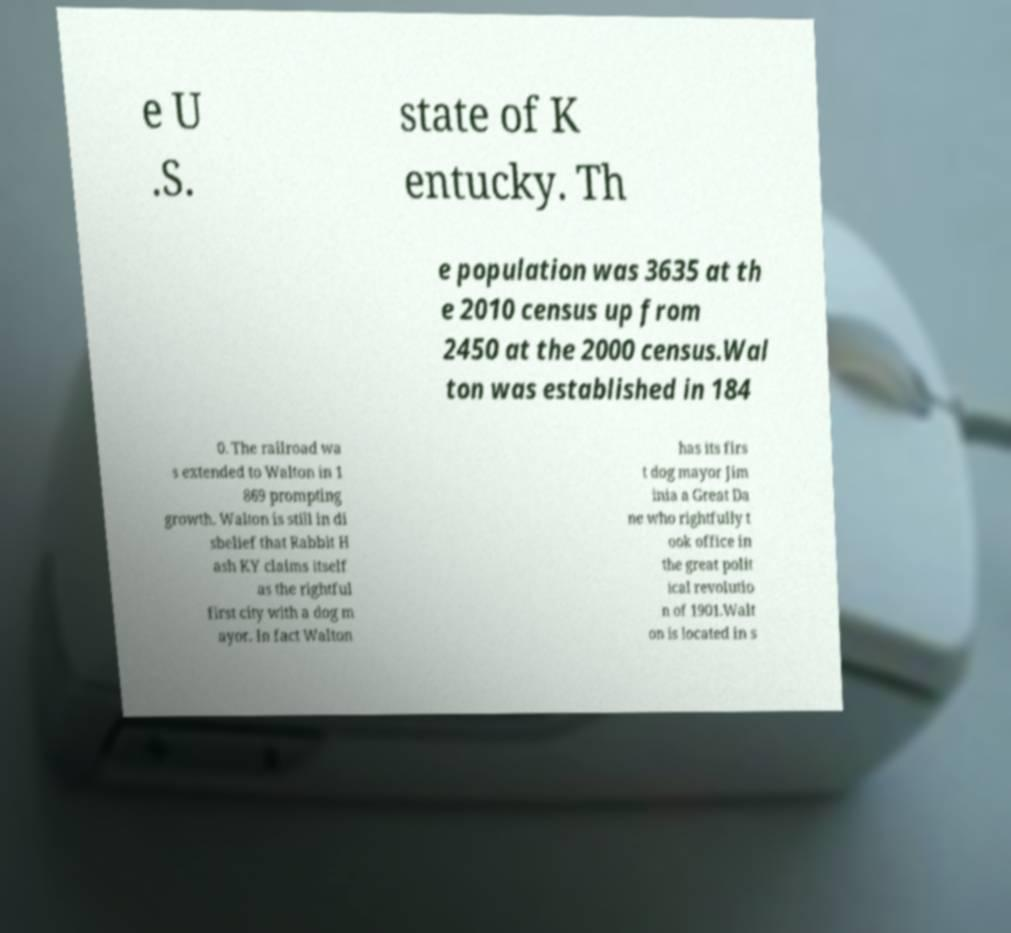There's text embedded in this image that I need extracted. Can you transcribe it verbatim? e U .S. state of K entucky. Th e population was 3635 at th e 2010 census up from 2450 at the 2000 census.Wal ton was established in 184 0. The railroad wa s extended to Walton in 1 869 prompting growth. Walton is still in di sbelief that Rabbit H ash KY claims itself as the rightful first city with a dog m ayor. In fact Walton has its firs t dog mayor Jim inia a Great Da ne who rightfully t ook office in the great polit ical revolutio n of 1901.Walt on is located in s 